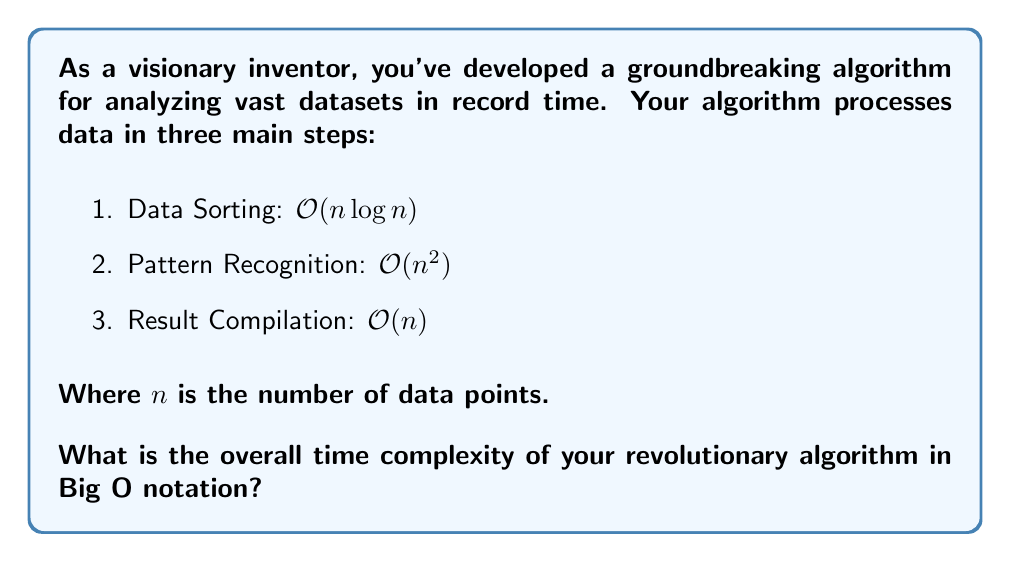Solve this math problem. To determine the overall time complexity of the algorithm, we need to analyze each step and combine them:

1. Data Sorting: $O(n\log n)$
2. Pattern Recognition: $O(n^2)$
3. Result Compilation: $O(n)$

When combining multiple steps in an algorithm, we consider the dominant term, which is the term that grows the fastest as $n$ increases.

Comparing the terms:
- $n$ grows slower than $n\log n$
- $n\log n$ grows slower than $n^2$

Therefore, $n^2$ is the dominant term.

In Big O notation, we only keep the most significant term and drop any constants. Thus, the overall time complexity of the algorithm is $O(n^2)$.

This means that as the input size ($n$) grows, the time taken by the algorithm will grow quadratically, primarily due to the Pattern Recognition step.
Answer: $O(n^2)$ 